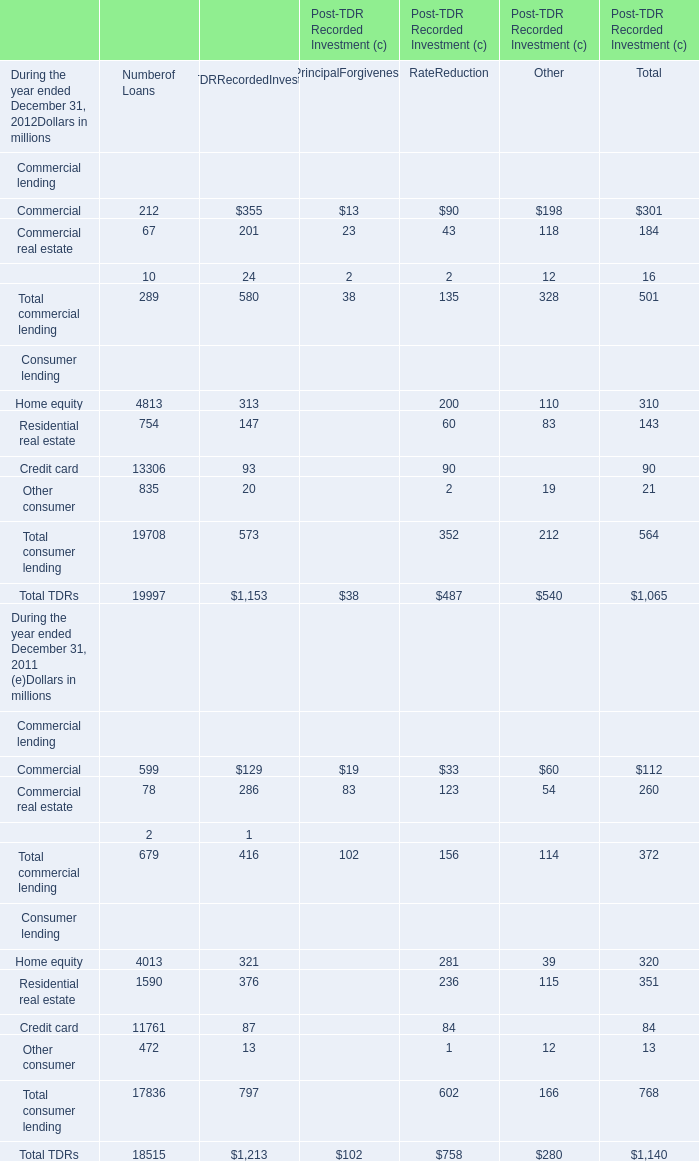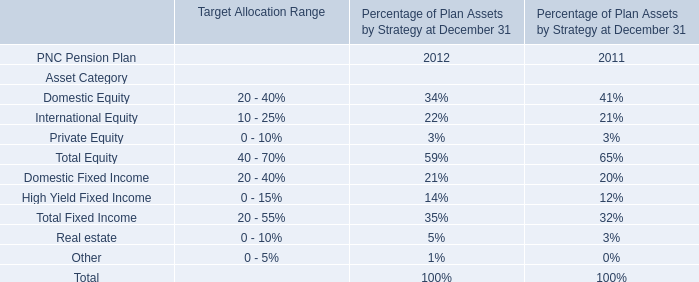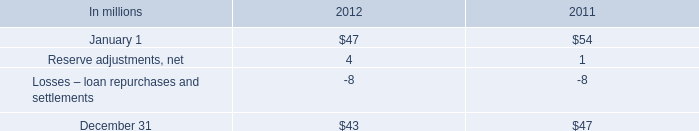As As the chart 0 shows,the value of the Total consumer lending for Rate Reduction during which year ended December 31, which year ranks higher? 
Answer: 2011. 